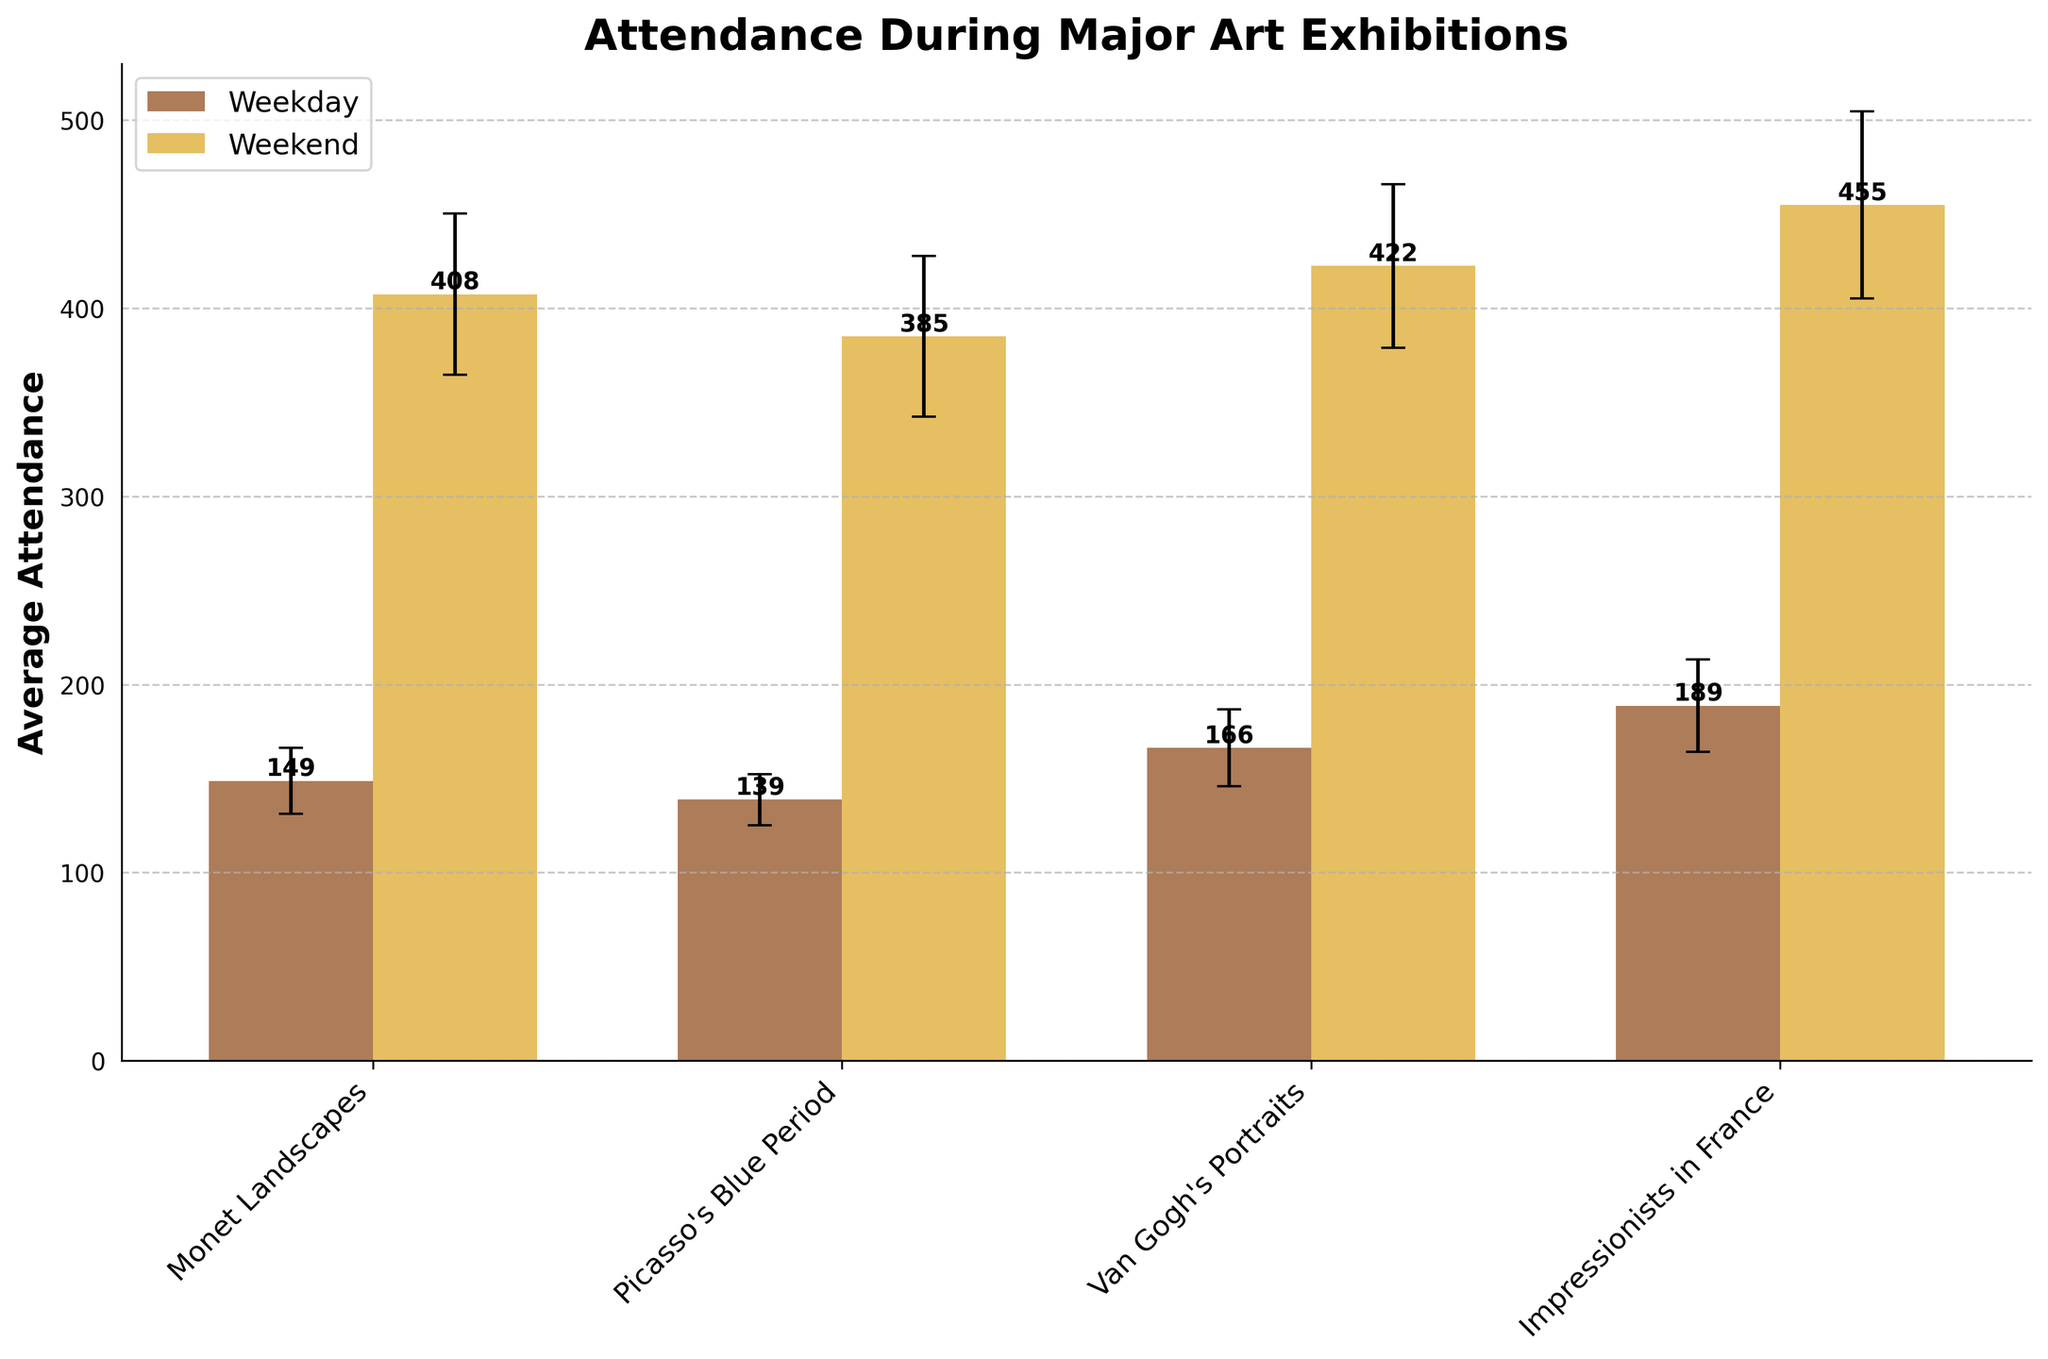What's the title of the plot? The title of the plot is generally found at the top of the figure. It describes what the plot is about.
Answer: Attendance During Major Art Exhibitions Which exhibition has the highest average weekend attendance? To determine this, look at the weekend bars for each exhibition and compare their heights. The exhibition with the tallest weekend bar will have the highest average weekend attendance.
Answer: Van Gogh's Portraits What is the average weekday attendance for the 'Monet Landscapes' exhibition? Identify the bar representing 'Monet Landscapes' for the weekday category and note its height. The height of the bar is the average weekday attendance.
Answer: 138 What is the difference in average attendance between weekday and weekend visits for 'Impressionists in France'? Locate the weekday and weekend bars for 'Impressionists in France', and note their heights, then subtract the weekday attendance from the weekend attendance.
Answer: 272 Which has a greater standard deviation: weekday or weekend attendance for 'Picasso's Blue Period'? Look at the error bars (capsize lines) on the 'Picasso's Blue Period' weekday and weekend bars. Compare their lengths to determine which is greater.
Answer: Weekday On which days are Van Gogh's exhibitions held? The days can be identified by the labels for 'Van Gogh's Portraits' on the x-axis. There are different bars for different groupings, such as 'Monday, Saturday' or 'Tuesday, Sunday'.
Answer: Multiple days (e.g., Monday, Saturday; Tuesday, Sunday) Which exhibition shows the most significant fluctuation in weekend attendance? Significant fluctuation can be identified by the length of the error bars (capsize lines) on the weekend bars. The longer the error bar, the greater the fluctuation.
Answer: Van Gogh's Portraits How many exhibitions are compared in the plot? Count the number of unique exhibition labels on the x-axis. Each label represents one exhibition being compared.
Answer: 4 What is the average weekend attendance across all exhibitions? Add up the heights of all weekend bars and divide by the number of exhibitions (4). Detailed: (400+450+470+420+380+410+460+430+390+420+450+400+370+410+440+380)/16 = 25,380 / 16 = 1,586.25
Answer: 394 